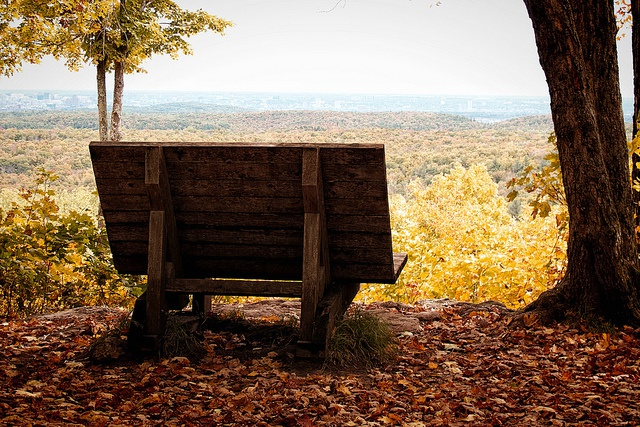Describe the objects in this image and their specific colors. I can see a bench in olive, black, maroon, and brown tones in this image. 